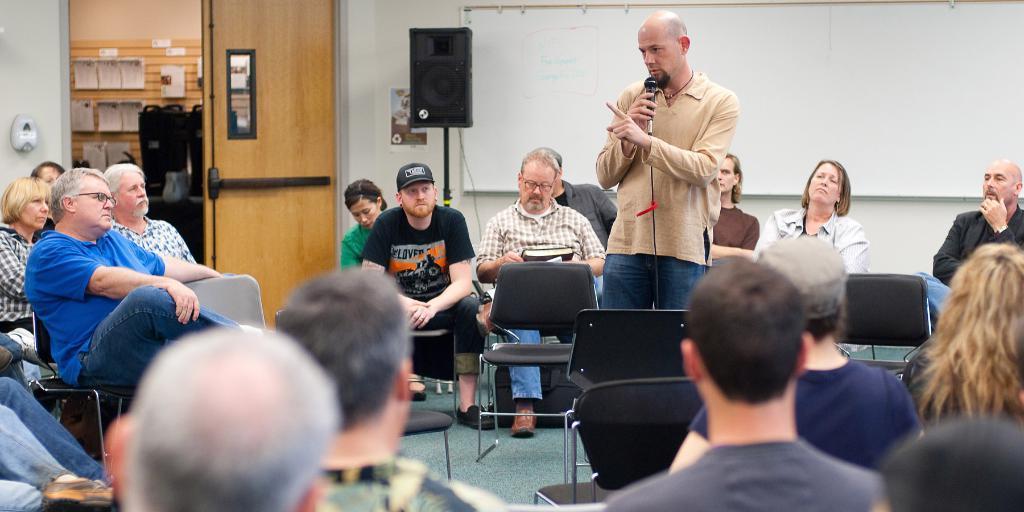How would you summarize this image in a sentence or two? In this image we can see many people are sitting on the chairs. A man is speaking into a microphone. There are many objects on the walls. There are few objects placed on the table. There is a loudspeaker in the image. There is a whiteboard on the wall in the image. 